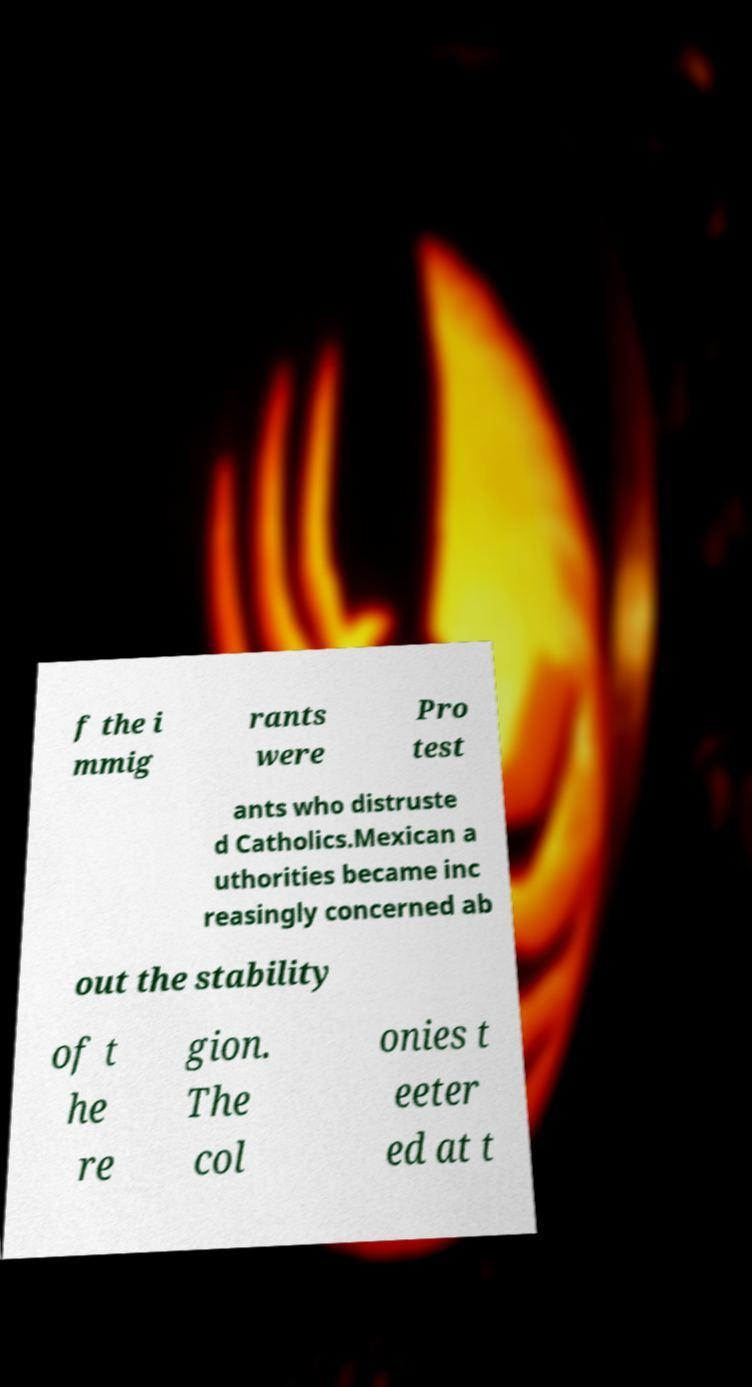Please identify and transcribe the text found in this image. f the i mmig rants were Pro test ants who distruste d Catholics.Mexican a uthorities became inc reasingly concerned ab out the stability of t he re gion. The col onies t eeter ed at t 